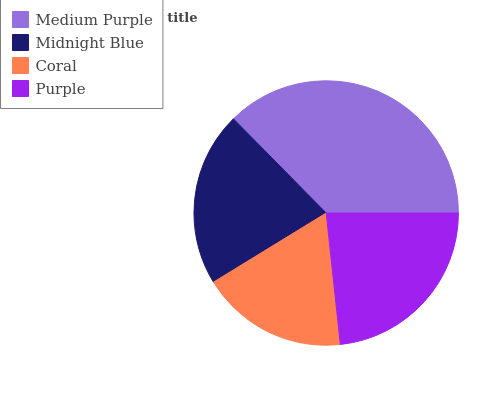Is Coral the minimum?
Answer yes or no. Yes. Is Medium Purple the maximum?
Answer yes or no. Yes. Is Midnight Blue the minimum?
Answer yes or no. No. Is Midnight Blue the maximum?
Answer yes or no. No. Is Medium Purple greater than Midnight Blue?
Answer yes or no. Yes. Is Midnight Blue less than Medium Purple?
Answer yes or no. Yes. Is Midnight Blue greater than Medium Purple?
Answer yes or no. No. Is Medium Purple less than Midnight Blue?
Answer yes or no. No. Is Purple the high median?
Answer yes or no. Yes. Is Midnight Blue the low median?
Answer yes or no. Yes. Is Coral the high median?
Answer yes or no. No. Is Medium Purple the low median?
Answer yes or no. No. 